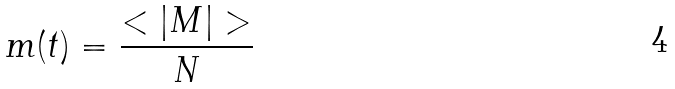Convert formula to latex. <formula><loc_0><loc_0><loc_500><loc_500>m ( t ) = \frac { < | M | > } { N }</formula> 